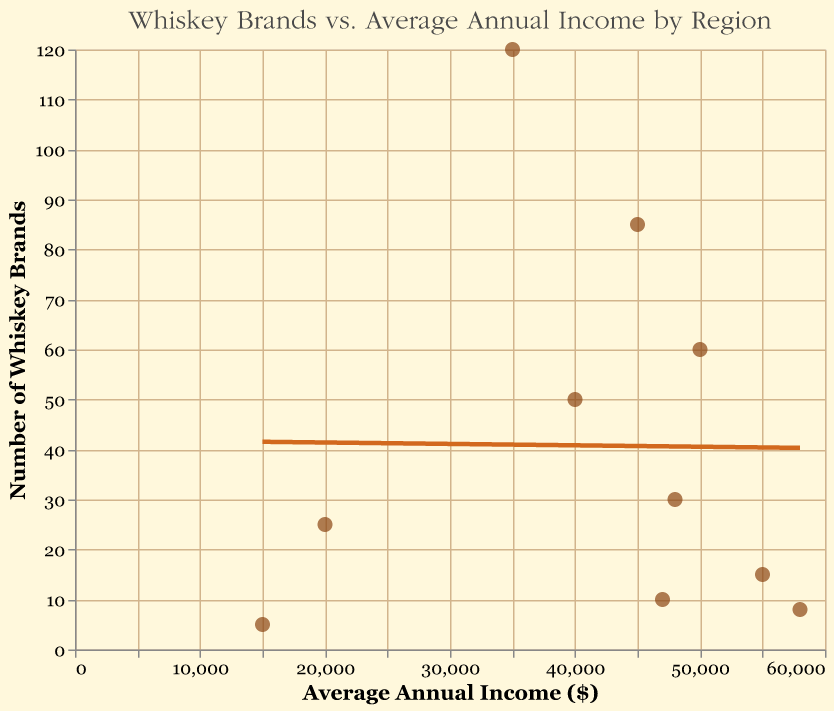What is the title of the figure? The title of the figure is displayed at the top and reads "Whiskey Brands vs. Average Annual Income by Region."
Answer: Whiskey Brands vs. Average Annual Income by Region What does the x-axis represent in the figure? The x-axis represents the average annual income of the regions, measured in dollars. It is labeled "Average Annual Income ($)."
Answer: Average annual income Which region has the highest number of whiskey brands? By looking at the top-most data point on the y-axis, we can see that Scotland has the highest number of whiskey brands, which is 120.
Answer: Scotland Which region has the lowest average annual income, and how many whiskey brands does it have? The region with the lowest average annual income is Mexico, with an income of $15,000 and it has 5 whiskey brands.
Answer: Mexico, 5 Compare the number of whiskey brands and the average annual income between Scotland and Japan. Scotland has 120 whiskey brands with an average annual income of $35,000, while Japan has 60 whiskey brands with an average annual income of $50,000. Scotland has more whiskey brands but a lower average annual income compared to Japan.
Answer: Scotland: 120 whiskey brands, $35,000; Japan: 60 whiskey brands, $50,000 What is the trend line suggesting about the relationship between average annual income and the number of whiskey brands? The trend line suggests that there is an inverse relationship between average annual income and the number of whiskey brands, meaning as the average annual income increases, the number of whiskey brands generally decreases.
Answer: Inverse relationship What is the average number of whiskey brands for regions with an average annual income below $30,000? Only Mexico and India have incomes below $30,000, with 5 and 25 whiskey brands respectively. The average is calculated as (5 + 25) / 2 = 15.
Answer: 15 How much higher is the average annual income in Australia compared to Ireland, and how does this relate to the number of whiskey brands? Australia has an income of $55,000 and Ireland has $40,000. The difference is $55,000 - $40,000 = $15,000. Australia has 15 whiskey brands, while Ireland has 50, indicating a higher income but fewer brands.
Answer: $15,000, Australia has fewer whiskey brands Identify the regions with an average annual income greater than $45,000. The regions with an average annual income greater than $45,000 are Japan ($50,000), Canada ($48,000), Australia ($55,000), Taiwan ($47,000), and Sweden ($58,000).
Answer: Japan, Canada, Australia, Taiwan, Sweden What color and size are the points representing each region on the scatter plot? The points representing each region are filled and brown in color, with a size of 100.
Answer: Brown, 100 